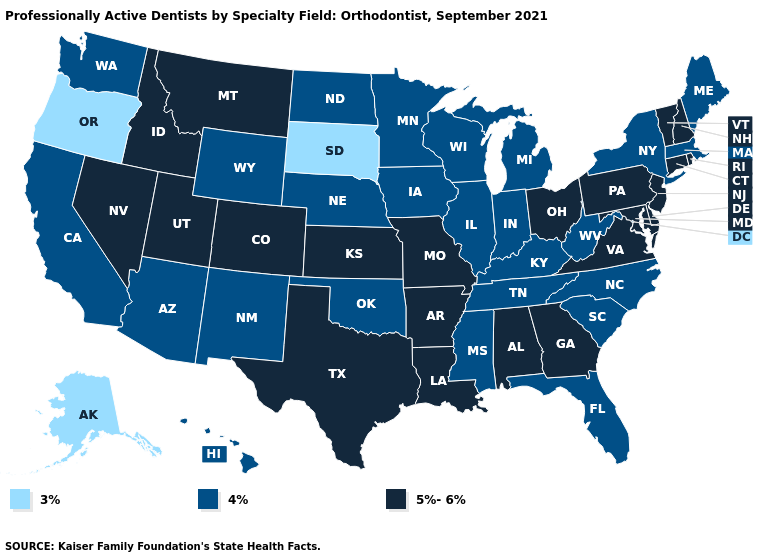Does Kentucky have a lower value than North Dakota?
Write a very short answer. No. Among the states that border Idaho , does Nevada have the highest value?
Answer briefly. Yes. Which states have the highest value in the USA?
Be succinct. Alabama, Arkansas, Colorado, Connecticut, Delaware, Georgia, Idaho, Kansas, Louisiana, Maryland, Missouri, Montana, Nevada, New Hampshire, New Jersey, Ohio, Pennsylvania, Rhode Island, Texas, Utah, Vermont, Virginia. What is the value of Florida?
Answer briefly. 4%. What is the highest value in the West ?
Be succinct. 5%-6%. Name the states that have a value in the range 4%?
Answer briefly. Arizona, California, Florida, Hawaii, Illinois, Indiana, Iowa, Kentucky, Maine, Massachusetts, Michigan, Minnesota, Mississippi, Nebraska, New Mexico, New York, North Carolina, North Dakota, Oklahoma, South Carolina, Tennessee, Washington, West Virginia, Wisconsin, Wyoming. Among the states that border West Virginia , does Kentucky have the lowest value?
Keep it brief. Yes. What is the value of Pennsylvania?
Write a very short answer. 5%-6%. What is the value of California?
Be succinct. 4%. What is the value of Oregon?
Short answer required. 3%. What is the highest value in states that border New Hampshire?
Write a very short answer. 5%-6%. What is the value of North Dakota?
Short answer required. 4%. What is the value of Florida?
Answer briefly. 4%. Name the states that have a value in the range 4%?
Quick response, please. Arizona, California, Florida, Hawaii, Illinois, Indiana, Iowa, Kentucky, Maine, Massachusetts, Michigan, Minnesota, Mississippi, Nebraska, New Mexico, New York, North Carolina, North Dakota, Oklahoma, South Carolina, Tennessee, Washington, West Virginia, Wisconsin, Wyoming. Among the states that border Oregon , which have the lowest value?
Short answer required. California, Washington. 